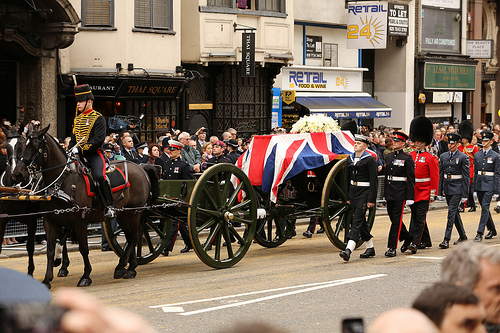What is pulled by the horse? The horse is pulling a wagon. 